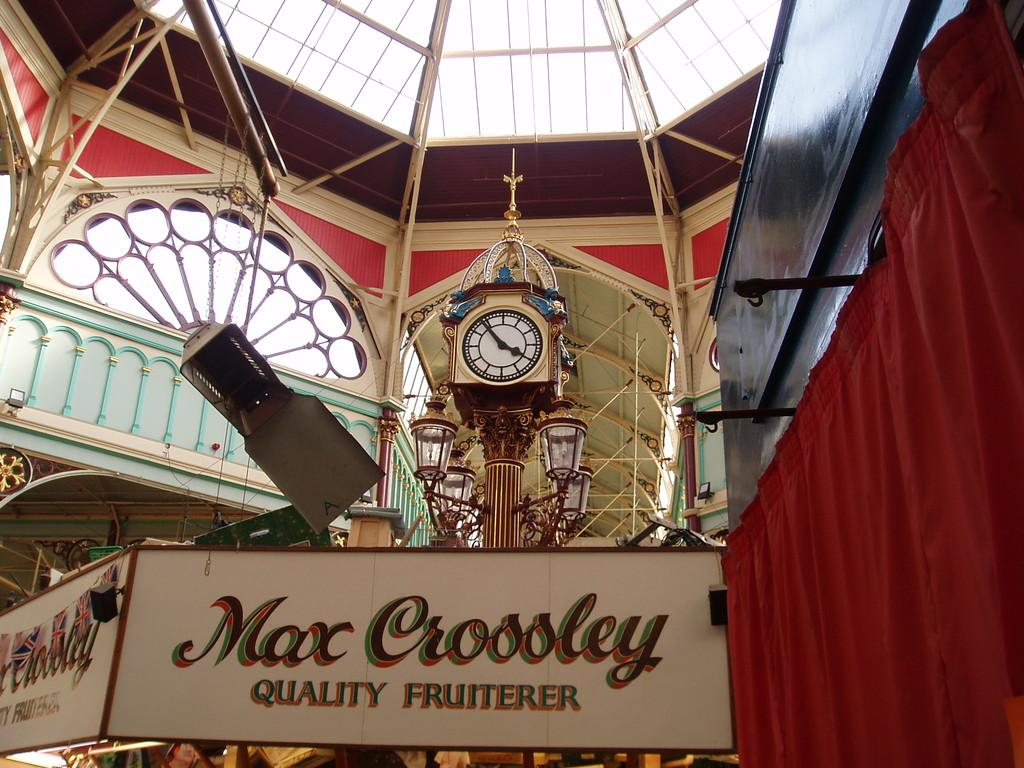<image>
Describe the image concisely. A sign in a building says the Max Crossley is a quality fruitier. 